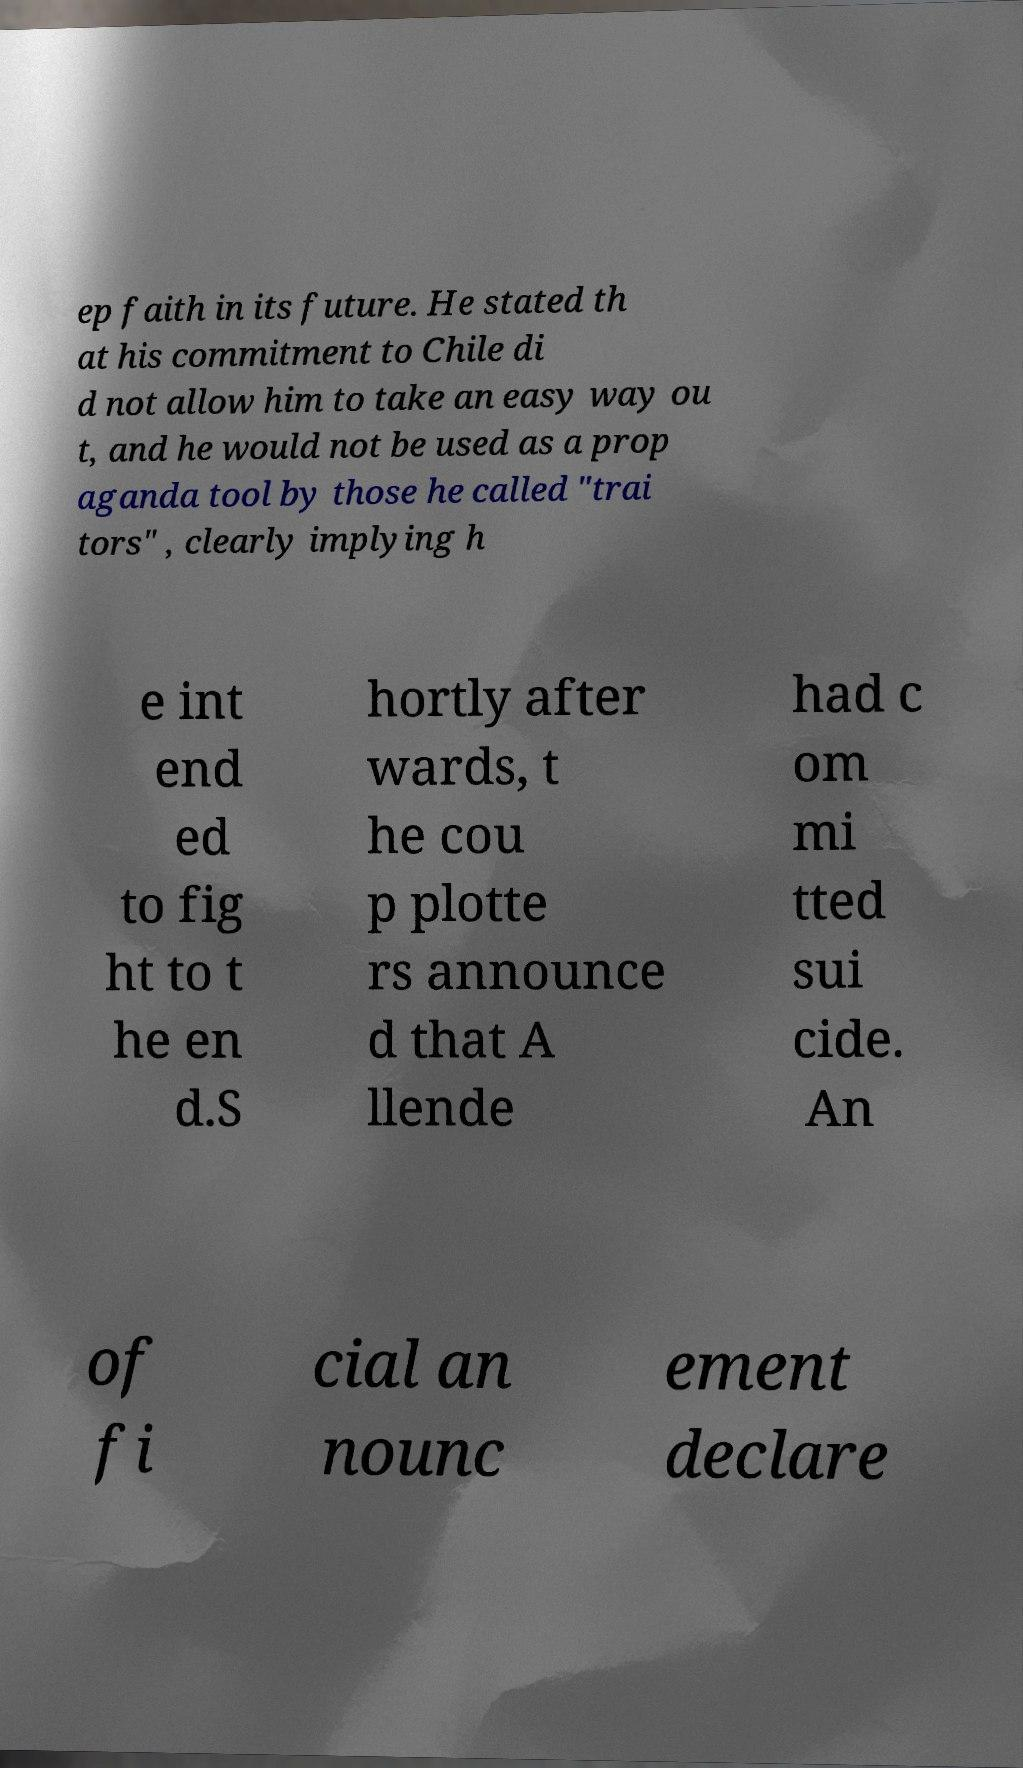Can you read and provide the text displayed in the image?This photo seems to have some interesting text. Can you extract and type it out for me? ep faith in its future. He stated th at his commitment to Chile di d not allow him to take an easy way ou t, and he would not be used as a prop aganda tool by those he called "trai tors" , clearly implying h e int end ed to fig ht to t he en d.S hortly after wards, t he cou p plotte rs announce d that A llende had c om mi tted sui cide. An of fi cial an nounc ement declare 